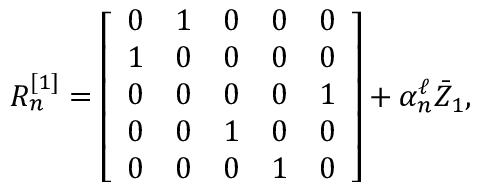<formula> <loc_0><loc_0><loc_500><loc_500>\begin{array} { r } { R _ { n } ^ { [ 1 ] } = \left [ \begin{array} { l l l l l } { 0 } & { 1 } & { 0 } & { 0 } & { 0 } \\ { 1 } & { 0 } & { 0 } & { 0 } & { 0 } \\ { 0 } & { 0 } & { 0 } & { 0 } & { 1 } \\ { 0 } & { 0 } & { 1 } & { 0 } & { 0 } \\ { 0 } & { 0 } & { 0 } & { 1 } & { 0 } \end{array} \right ] + \alpha _ { n } ^ { \ell } \bar { Z } _ { 1 } , } \end{array}</formula> 